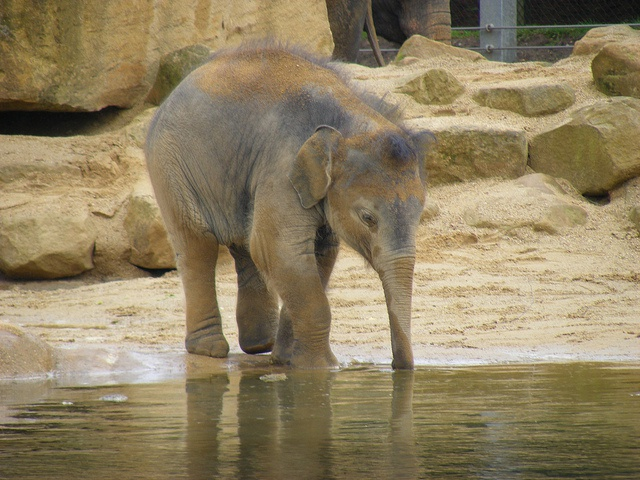Describe the objects in this image and their specific colors. I can see a elephant in maroon, gray, and tan tones in this image. 